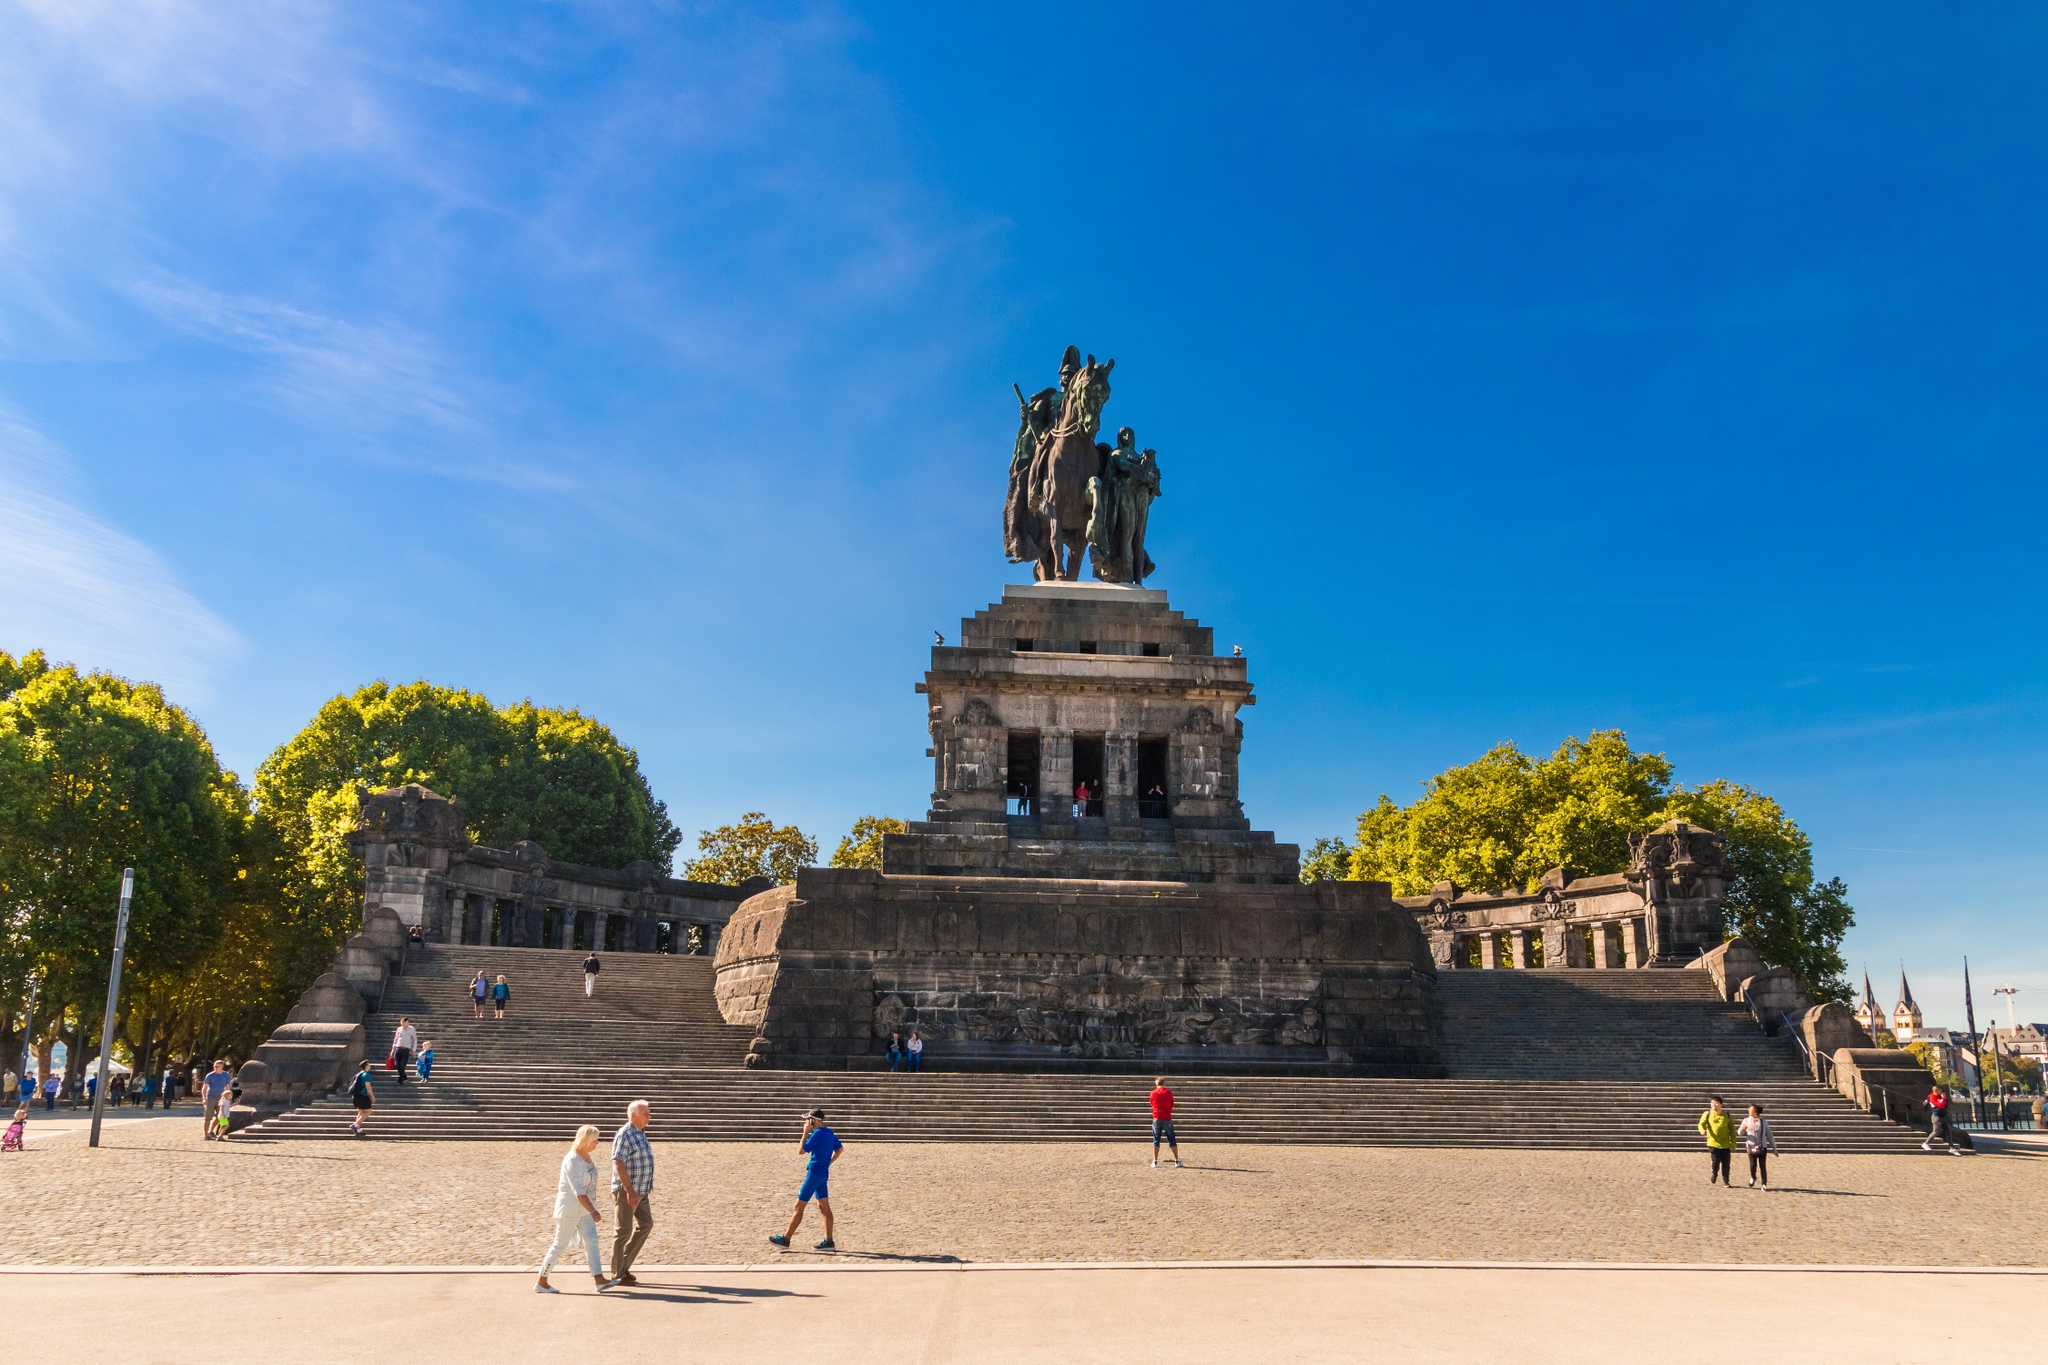What other historical events have taken place at Deutsches Eck? Deutsches Eck has witnessed multiple pivotal events in German history. Originally dedicated to the Order of Teutonic Knights, the site evolved into a nationalistic symbol during the German Empire under William I. Post-World War II, the site, and statue were damaged, symbolizing the fractured state of Germany. However, it was restored after reunification in 1993, coming to represent unity and peace in modern Germany. The recurring themes of nationalism, turmoil, and unity make Deutsches Eck a profoundly historical site. 